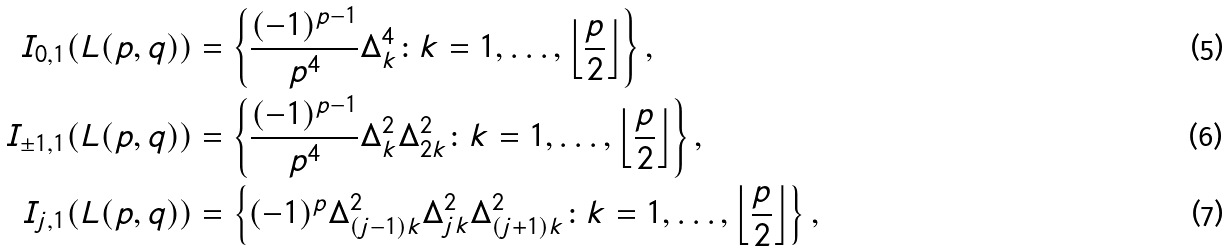Convert formula to latex. <formula><loc_0><loc_0><loc_500><loc_500>I _ { 0 , 1 } ( L ( p , q ) ) & = \left \{ \frac { ( - 1 ) ^ { p - 1 } } { p ^ { 4 } } \Delta _ { k } ^ { 4 } \colon k = 1 , \dots , \left \lfloor { \frac { p } { 2 } } \right \rfloor \right \} , \\ I _ { \pm 1 , 1 } ( L ( p , q ) ) & = \left \{ \frac { ( - 1 ) ^ { p - 1 } } { p ^ { 4 } } \Delta _ { k } ^ { 2 } \Delta _ { 2 k } ^ { 2 } \colon k = 1 , \dots , \left \lfloor { \frac { p } { 2 } } \right \rfloor \right \} , \\ I _ { j , 1 } ( L ( p , q ) ) & = \left \{ ( - 1 ) ^ { p } \Delta _ { ( j - 1 ) k } ^ { 2 } \Delta _ { j k } ^ { 2 } \Delta _ { ( j + 1 ) k } ^ { 2 } \colon k = 1 , \dots , \left \lfloor { \frac { p } { 2 } } \right \rfloor \right \} ,</formula> 